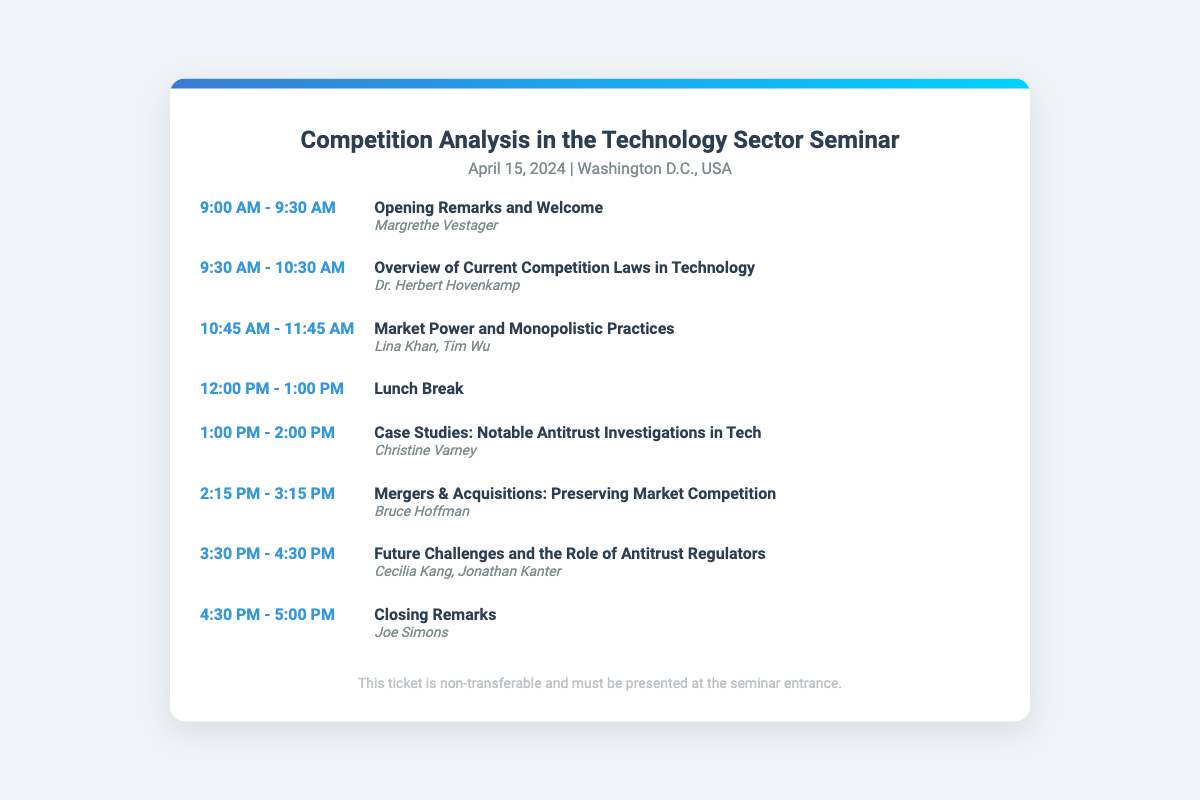What is the date of the seminar? The seminar is scheduled for April 15, 2024, as mentioned in the document.
Answer: April 15, 2024 Who is delivering the opening remarks? The document states that Margrethe Vestager is the speaker for the opening remarks.
Answer: Margrethe Vestager What session follows the lunch break? The session after the lunch break is titled "Case Studies: Notable Antitrust Investigations in Tech."
Answer: Case Studies: Notable Antitrust Investigations in Tech How long is the lunch break? The lunch break is scheduled for one hour, as indicated in the document.
Answer: 1 hour What is the title of the session at 2:15 PM? The session scheduled for 2:15 PM is titled "Mergers & Acquisitions: Preserving Market Competition."
Answer: Mergers & Acquisitions: Preserving Market Competition Who are the speakers for the session on market power? Lina Khan and Tim Wu are the speakers for the session titled "Market Power and Monopolistic Practices."
Answer: Lina Khan, Tim Wu What time does the seminar officially start? The seminar officially starts at 9:00 AM according to the document.
Answer: 9:00 AM What is the focus of the final session? The final session is focused on "Future Challenges and the Role of Antitrust Regulators."
Answer: Future Challenges and the Role of Antitrust Regulators 